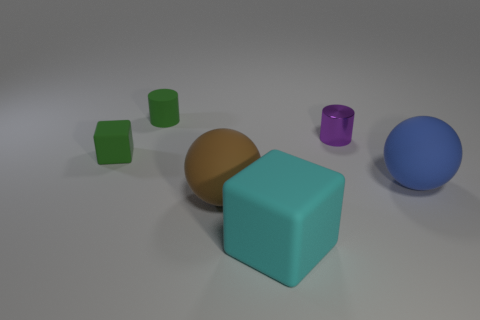Add 1 small green things. How many objects exist? 7 Subtract all cylinders. How many objects are left? 4 Add 2 small things. How many small things are left? 5 Add 6 red matte objects. How many red matte objects exist? 6 Subtract 0 red cylinders. How many objects are left? 6 Subtract all green matte cylinders. Subtract all brown matte things. How many objects are left? 4 